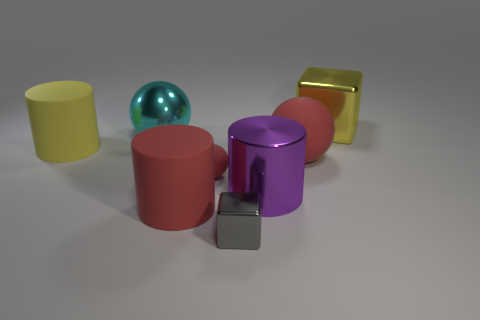Subtract all small red balls. How many balls are left? 2 Subtract all brown blocks. How many red balls are left? 2 Add 1 tiny gray cubes. How many objects exist? 9 Subtract all cyan spheres. How many spheres are left? 2 Subtract all balls. How many objects are left? 5 Subtract 1 cubes. How many cubes are left? 1 Subtract 1 gray blocks. How many objects are left? 7 Subtract all red cylinders. Subtract all gray blocks. How many cylinders are left? 2 Subtract all tiny blue rubber cylinders. Subtract all large cyan metal things. How many objects are left? 7 Add 2 cyan things. How many cyan things are left? 3 